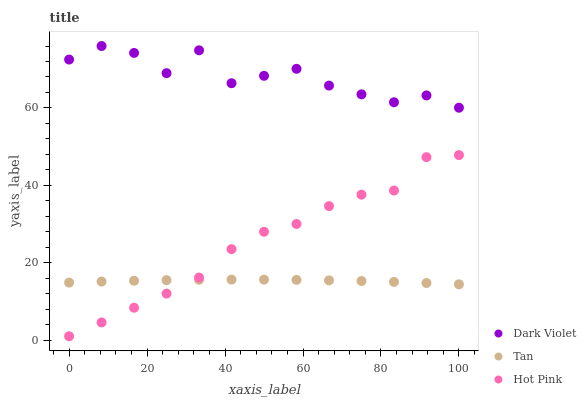Does Tan have the minimum area under the curve?
Answer yes or no. Yes. Does Dark Violet have the maximum area under the curve?
Answer yes or no. Yes. Does Hot Pink have the minimum area under the curve?
Answer yes or no. No. Does Hot Pink have the maximum area under the curve?
Answer yes or no. No. Is Tan the smoothest?
Answer yes or no. Yes. Is Dark Violet the roughest?
Answer yes or no. Yes. Is Hot Pink the smoothest?
Answer yes or no. No. Is Hot Pink the roughest?
Answer yes or no. No. Does Hot Pink have the lowest value?
Answer yes or no. Yes. Does Dark Violet have the lowest value?
Answer yes or no. No. Does Dark Violet have the highest value?
Answer yes or no. Yes. Does Hot Pink have the highest value?
Answer yes or no. No. Is Hot Pink less than Dark Violet?
Answer yes or no. Yes. Is Dark Violet greater than Tan?
Answer yes or no. Yes. Does Hot Pink intersect Tan?
Answer yes or no. Yes. Is Hot Pink less than Tan?
Answer yes or no. No. Is Hot Pink greater than Tan?
Answer yes or no. No. Does Hot Pink intersect Dark Violet?
Answer yes or no. No. 